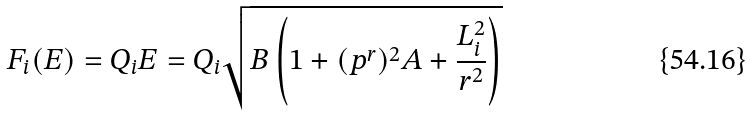Convert formula to latex. <formula><loc_0><loc_0><loc_500><loc_500>F _ { i } ( E ) = Q _ { i } E = Q _ { i } \sqrt { B \left ( 1 + ( p ^ { r } ) ^ { 2 } A + \frac { L _ { i } ^ { 2 } } { r ^ { 2 } } \right ) }</formula> 